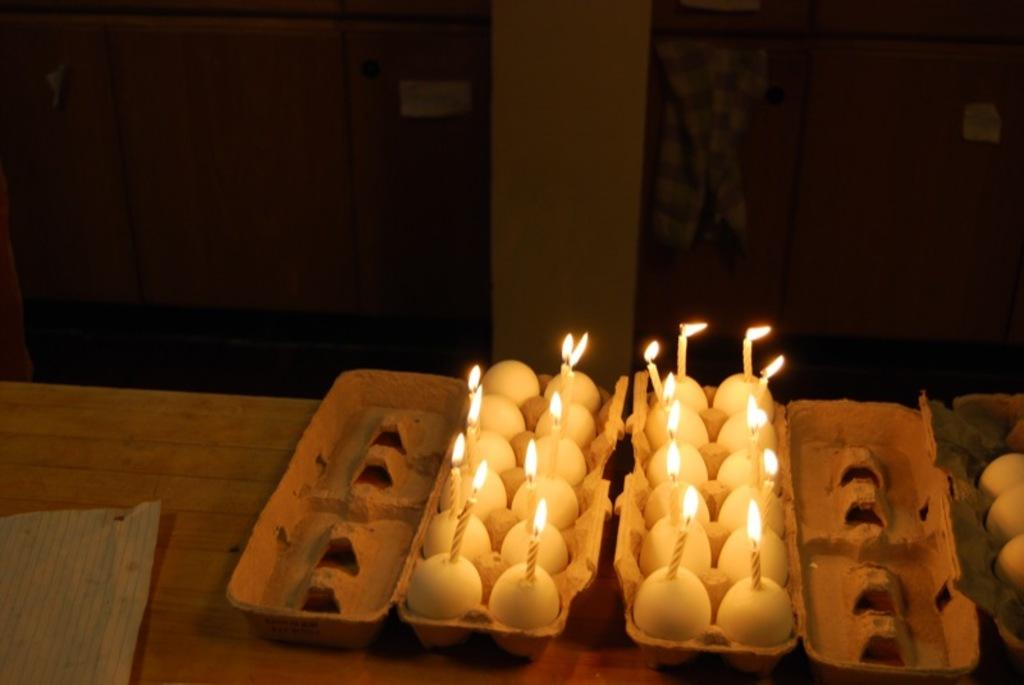What objects are on the table in the image? There are boxes, eggs, and candles on the table in the image. What is located near a door in the image? There is cloth near a door in the image. How many doors can be seen in the image? There are two doors in the image, one near the table and another on the left side. What architectural feature is present in the image? There is a pillar in the image. What type of chicken is sitting on the table in the image? There is no chicken present on the table in the image. How many insects can be seen crawling on the pillar in the image? There are no insects visible on the pillar in the image. 